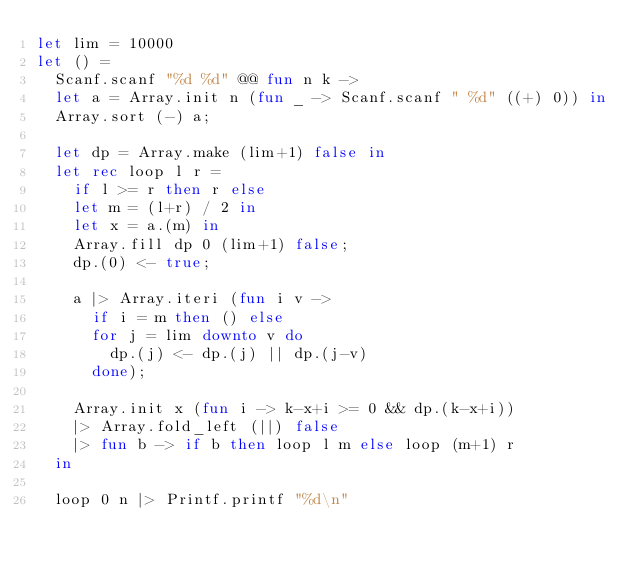<code> <loc_0><loc_0><loc_500><loc_500><_OCaml_>let lim = 10000
let () =
  Scanf.scanf "%d %d" @@ fun n k ->
  let a = Array.init n (fun _ -> Scanf.scanf " %d" ((+) 0)) in
  Array.sort (-) a;

  let dp = Array.make (lim+1) false in
  let rec loop l r =
    if l >= r then r else
    let m = (l+r) / 2 in
    let x = a.(m) in
    Array.fill dp 0 (lim+1) false;
    dp.(0) <- true;

    a |> Array.iteri (fun i v -> 
      if i = m then () else
      for j = lim downto v do
        dp.(j) <- dp.(j) || dp.(j-v)
      done);

    Array.init x (fun i -> k-x+i >= 0 && dp.(k-x+i))
    |> Array.fold_left (||) false
    |> fun b -> if b then loop l m else loop (m+1) r
  in

  loop 0 n |> Printf.printf "%d\n"</code> 